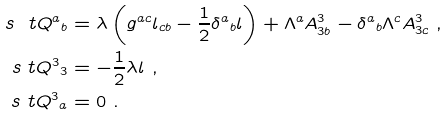<formula> <loc_0><loc_0><loc_500><loc_500>s { \ t Q } ^ { a } { _ { b } } & = \lambda \left ( g ^ { a c } l _ { c b } - \frac { 1 } { 2 } \delta ^ { a } { _ { b } } l \right ) + \Lambda ^ { a } A ^ { 3 } _ { 3 b } - \delta ^ { a } { _ { b } } \Lambda ^ { c } A ^ { 3 } _ { 3 c } \ , \\ s { \ t Q } ^ { 3 } { _ { 3 } } & = - \frac { 1 } { 2 } \lambda l \ , \\ s { \ t Q } ^ { 3 } { _ { a } } & = 0 \ .</formula> 